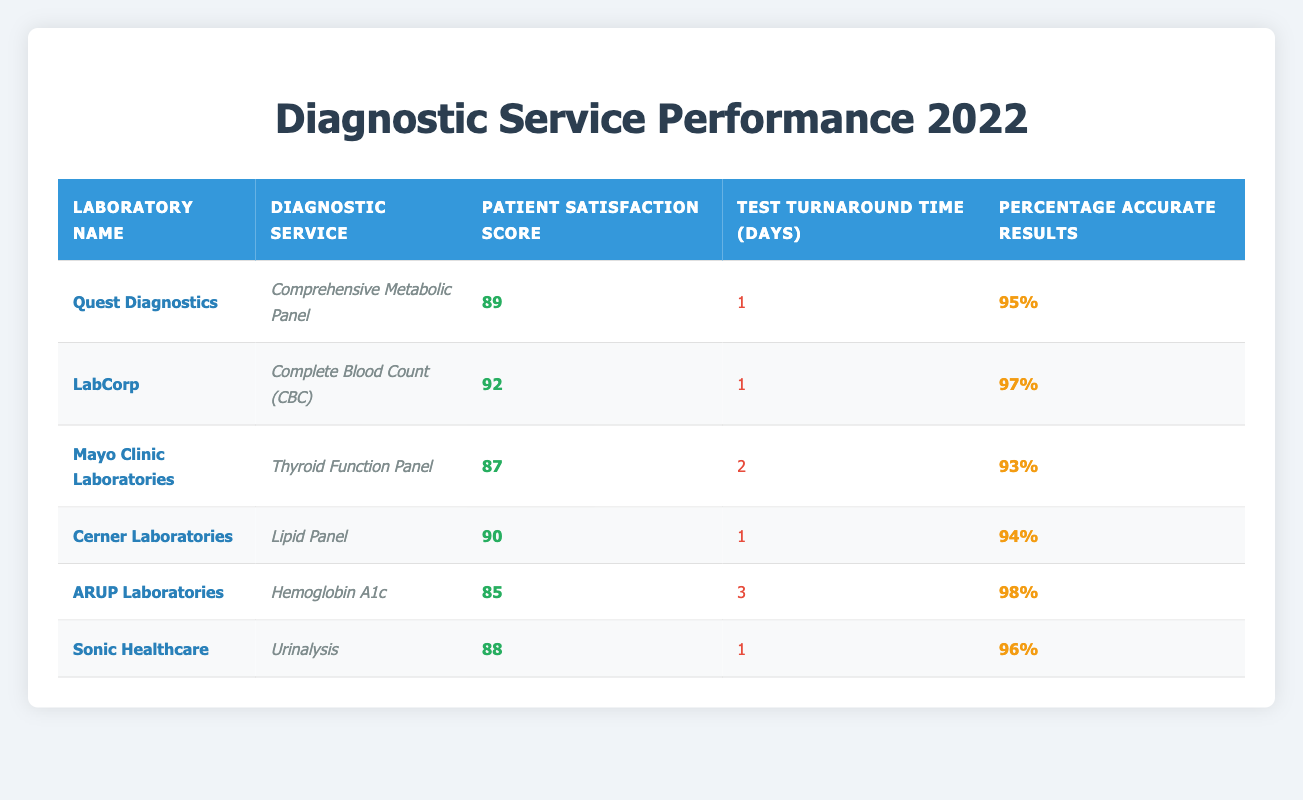What is the highest patient satisfaction score among the diagnostic services listed? The patient satisfaction scores listed are 89, 92, 87, 90, 85, and 88. The highest score among these is 92, which corresponds to LabCorp's Complete Blood Count (CBC).
Answer: 92 Which laboratory has the longest test turnaround time? The test turnaround times listed are 1, 1, 2, 1, 3, and 1 days. The longest turnaround time is 3 days, associated with ARUP Laboratories' Hemoglobin A1c service.
Answer: 3 days Is the percentage of accurate results for the Comprehensive Metabolic Panel higher than 95%? The percentage of accurate results for the Comprehensive Metabolic Panel from Quest Diagnostics is 95%. Since "higher than 95%" means strictly greater, it would be false.
Answer: No What is the average patient satisfaction score for Laboratories with a turnaround time of 1 day? The laboratories with a turnaround time of 1 day are Quest Diagnostics (89), LabCorp (92), Cerner Laboratories (90), and Sonic Healthcare (88). Summing these scores gives 89 + 92 + 90 + 88 = 359. There are 4 data points, so the average is 359 / 4 = 89.75.
Answer: 89.75 Which laboratory scored below 90 for patient satisfaction? The laboratories with patient satisfaction scores below 90 are Mayo Clinic Laboratories (87) and ARUP Laboratories (85).
Answer: 2 laboratories What is the percentage of accurate results for the Lipid Panel? The percentage of accurate results listed for Cerner Laboratories' Lipid Panel is 94%.
Answer: 94% Are all diagnostic services provided by LabCorp tied to patient satisfaction scores above 90? LabCorp only provided the Complete Blood Count (CBC) service, which has a patient satisfaction score of 92, thus it is true that all their services have scores above 90.
Answer: Yes Which laboratory offers a service with both the highest accuracy percentage and patient satisfaction score? To find this, we check the accuracy percentages alongside their satisfaction scores. LabCorp has the highest satisfaction score (92) and its accuracy percentage is 97%. This is higher than any other lab that has a satisfaction score above 90. Hence, LabCorp offers the service with both the highest accuracy percentage and patient satisfaction score.
Answer: LabCorp 